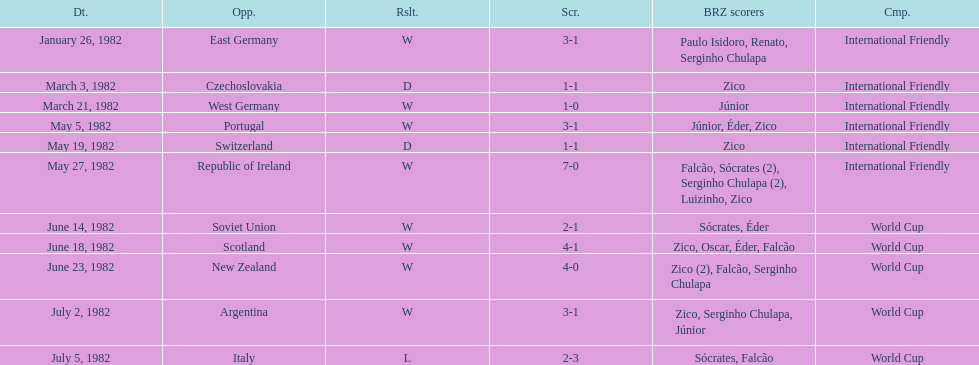How many times did brazil play west germany during the 1982 season? 1. 